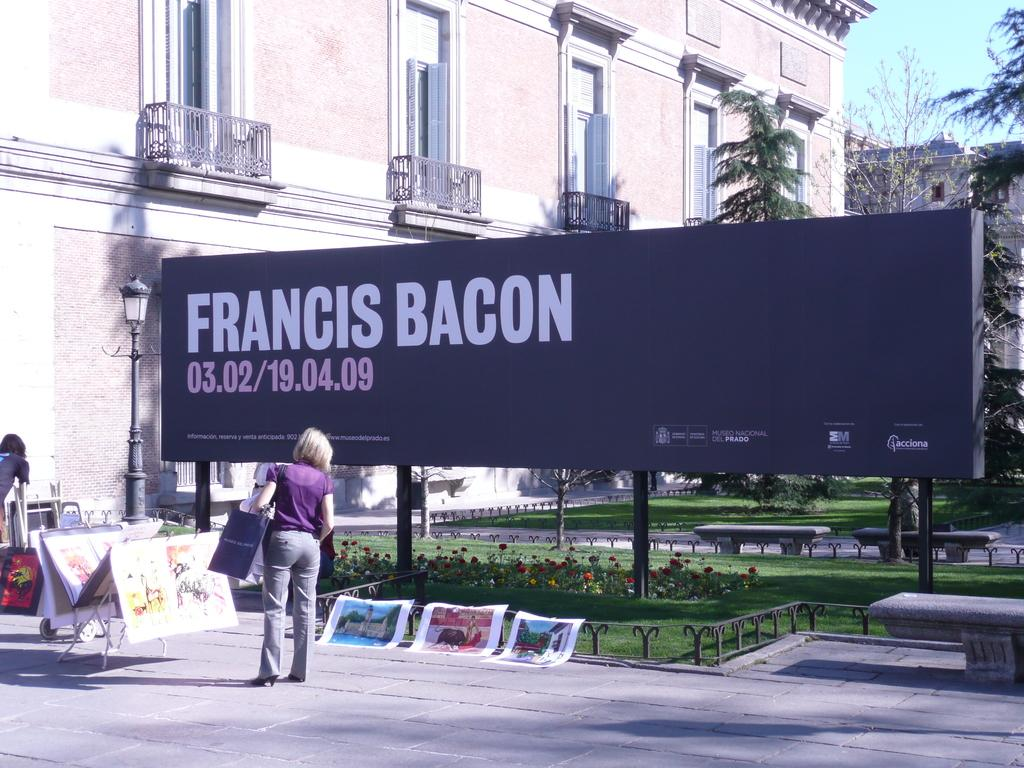<image>
Share a concise interpretation of the image provided. A blackboard has the words Francis Bacon written on it with paintings on display beneath it 